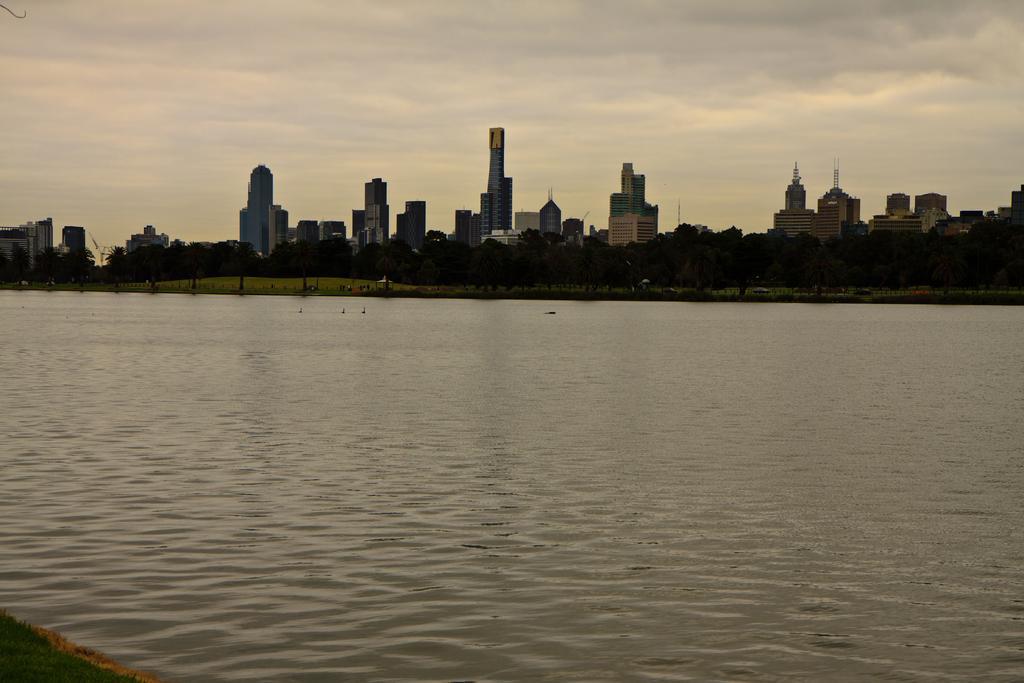Describe this image in one or two sentences. In this image we can see many buildings, there are trees, there is a grass, there is the water, the sky is cloudy. 